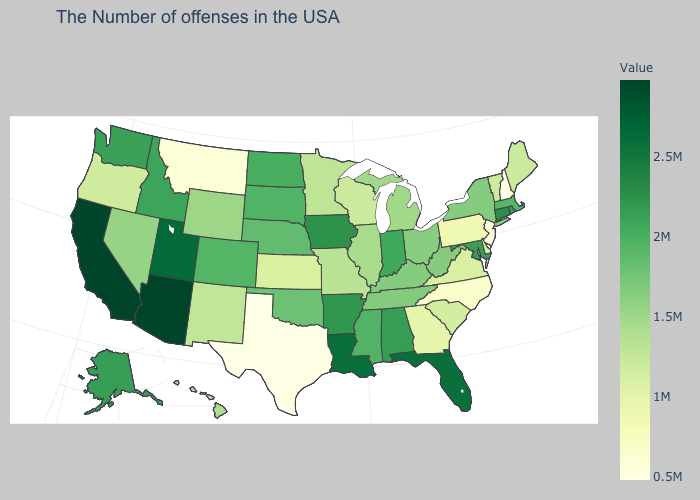Among the states that border Texas , does Louisiana have the highest value?
Short answer required. Yes. Does California have the highest value in the USA?
Give a very brief answer. Yes. Does New Jersey have the lowest value in the Northeast?
Quick response, please. No. Does Utah have the highest value in the USA?
Keep it brief. No. Does Colorado have the lowest value in the West?
Short answer required. No. 